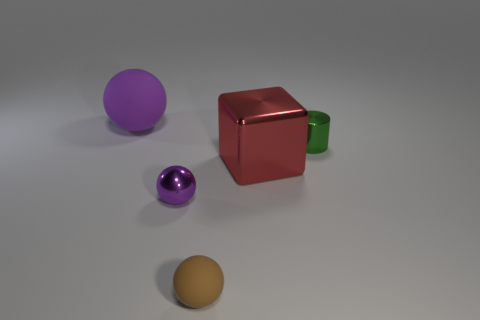Subtract all cyan cylinders. Subtract all brown cubes. How many cylinders are left? 1 Add 2 large blue balls. How many objects exist? 7 Subtract all balls. How many objects are left? 2 Subtract all large brown matte things. Subtract all large purple matte balls. How many objects are left? 4 Add 5 small brown matte balls. How many small brown matte balls are left? 6 Add 5 green cylinders. How many green cylinders exist? 6 Subtract 0 purple blocks. How many objects are left? 5 